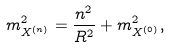Convert formula to latex. <formula><loc_0><loc_0><loc_500><loc_500>m ^ { 2 } _ { X ^ { ( n ) } } = \frac { n ^ { 2 } } { R ^ { 2 } } + m ^ { 2 } _ { X ^ { ( 0 ) } } ,</formula> 